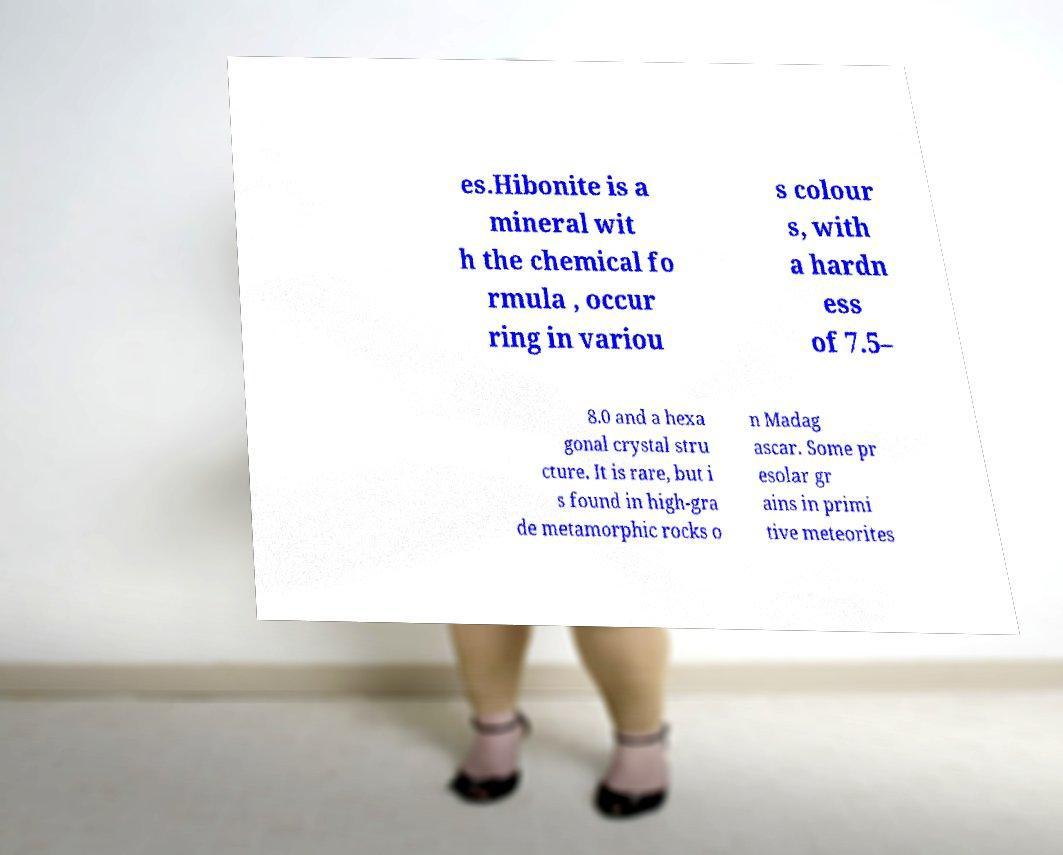There's text embedded in this image that I need extracted. Can you transcribe it verbatim? es.Hibonite is a mineral wit h the chemical fo rmula , occur ring in variou s colour s, with a hardn ess of 7.5– 8.0 and a hexa gonal crystal stru cture. It is rare, but i s found in high-gra de metamorphic rocks o n Madag ascar. Some pr esolar gr ains in primi tive meteorites 